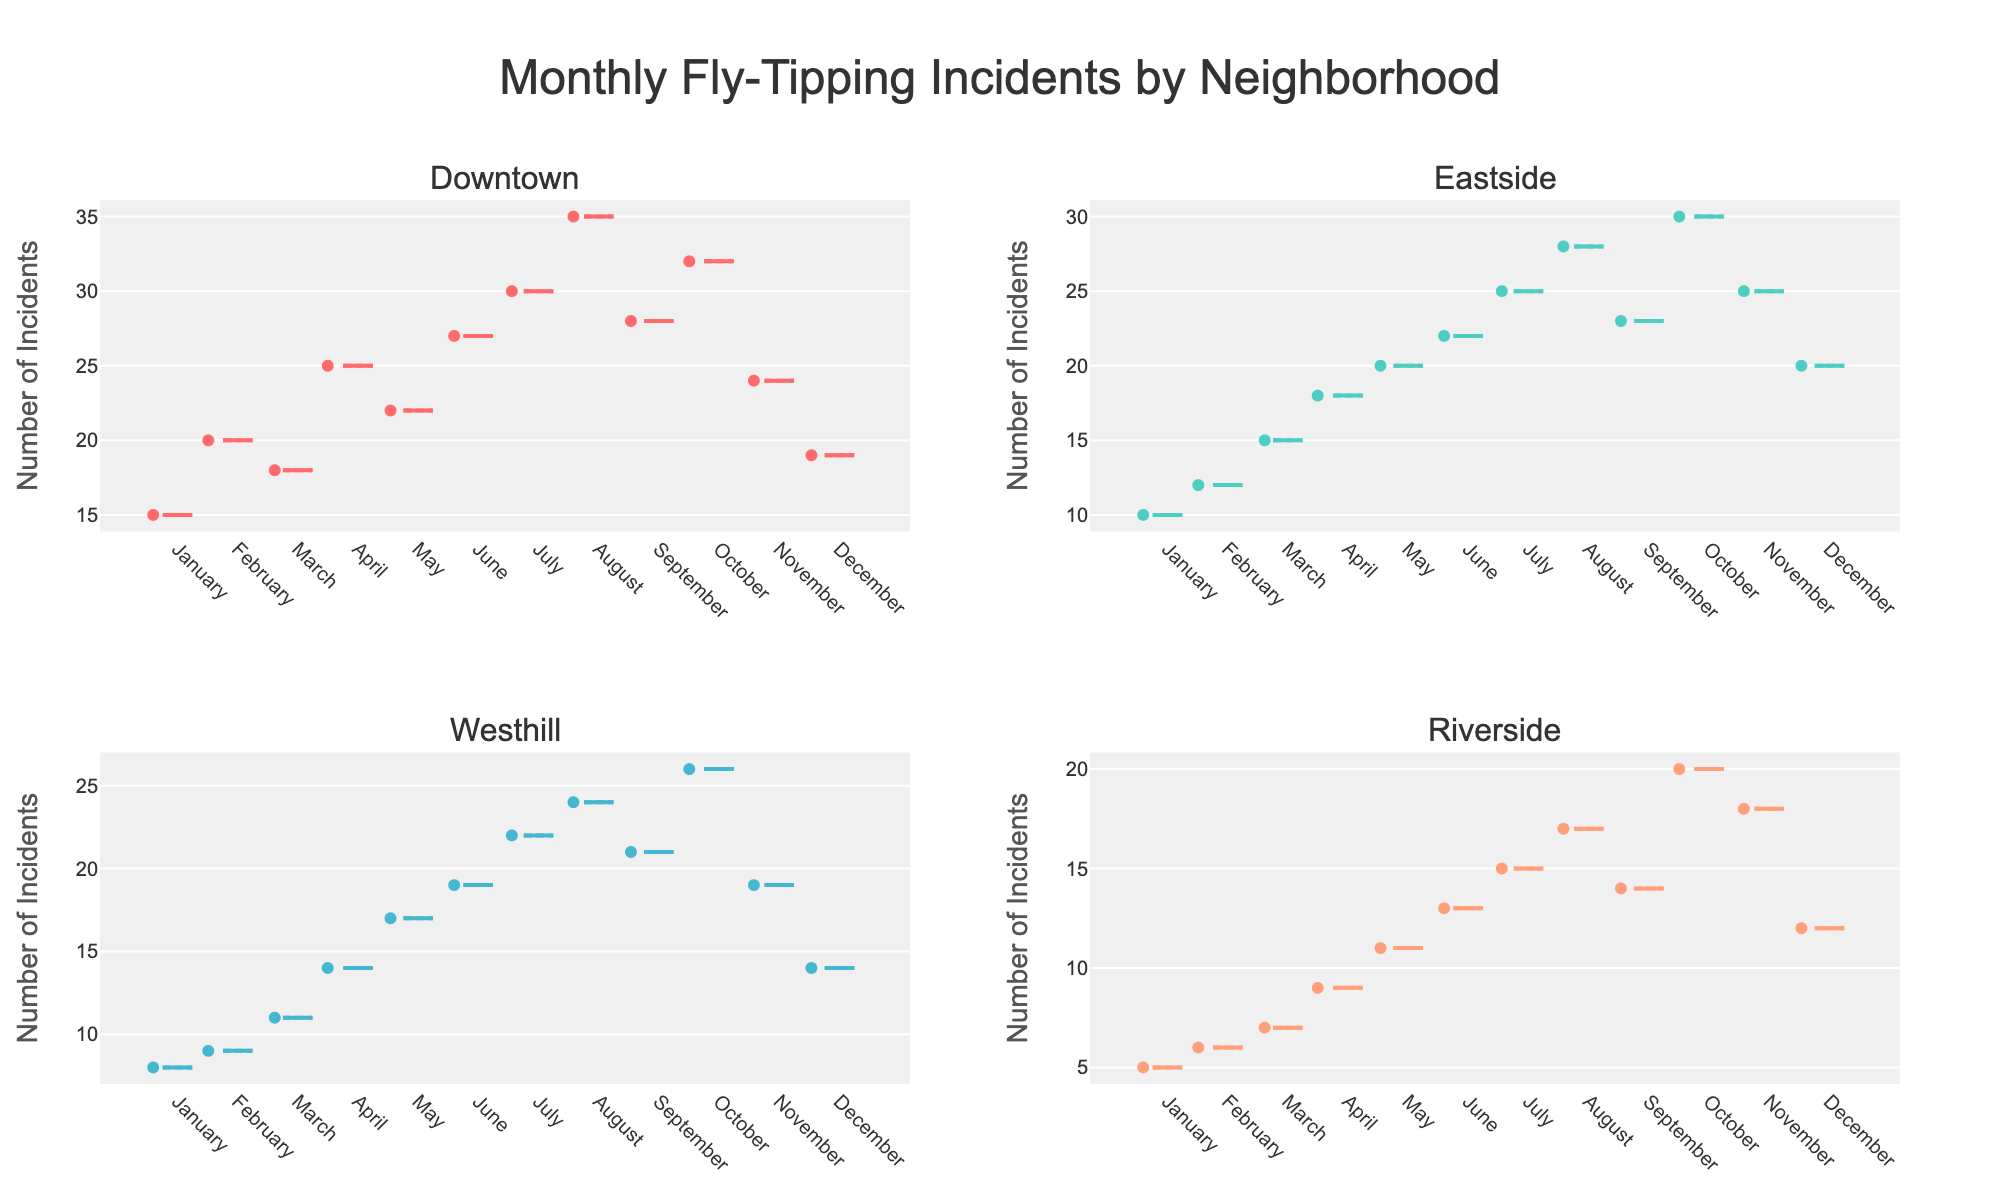How many neighborhoods are represented in the box plots? By looking at the subplot titles or the number of unique box plots, we can count the distinct neighborhoods. There are four distinct neighborhoods represented in the figure.
Answer: Four What is the title of the overall figure? The title is usually found at the top of the overall figure. The title of the figure is "Monthly Fly-Tipping Incidents by Neighborhood".
Answer: Monthly Fly-Tipping Incidents by Neighborhood Which neighborhood observed the highest number of fly-tipping incidents in July? By observing the July data points in each subplot, we can identify the highest value. Downtown had the highest number of fly-tipping incidents in July with 30 incidents.
Answer: Downtown Which two months have the highest median number of incidents for Eastside? In the box plot for Eastside, we observe the median line within each box. The months with the highest median values are October and November.
Answer: October, November What is the difference in the maximum number of fly-tipping incidents between Downtown and Riverside for the month of August? By looking at the August data points in the subplots for Downtown and Riverside, we find the maximum values. Downtown has a maximum of 35 incidents, and Riverside has a maximum of 17 incidents, so the difference is 35 - 17 = 18.
Answer: 18 During which month did Westhill record the fewest fly-tipping incidents? By examining the box plots for Westhill, the month with the minimum lower whisker is identified. Westhill recorded the fewest incidents in January with 8 incidents.
Answer: January How does the trend of fly-tipping incidents in Downtown change over the year? To observe the trend, we track the y-values of each month for Downtown. The trend shows a general increase in incidents from January to August, with a peak in August, followed by a slight decrease in subsequent months.
Answer: Increasing then decreasing Which neighborhood has the most consistent (least variable) number of fly-tipping incidents throughout the year? The consistency can be determined by the length of the boxes and whiskers. Riverside, having shorter whiskers and boxes relative to other neighborhoods, indicates the least variability.
Answer: Riverside What is the average of the median fly-tipping incidents in April for all neighborhoods? By identifying the median lines in the April boxes for each neighborhood and averaging them. Downtown: 25, Eastside: 18, Westhill: 14, Riverside: 9. Average = (25 + 18 + 14 + 9) / 4 = 66 / 4 = 16.5.
Answer: 16.5 Which neighborhood experiences the highest variability in incidents, and how can you tell? Variability is shown by the range (distance between upper and lower whiskers) of the box plots. Downtown has the highest variability as it has the widest boxes and longest whiskers.
Answer: Downtown 